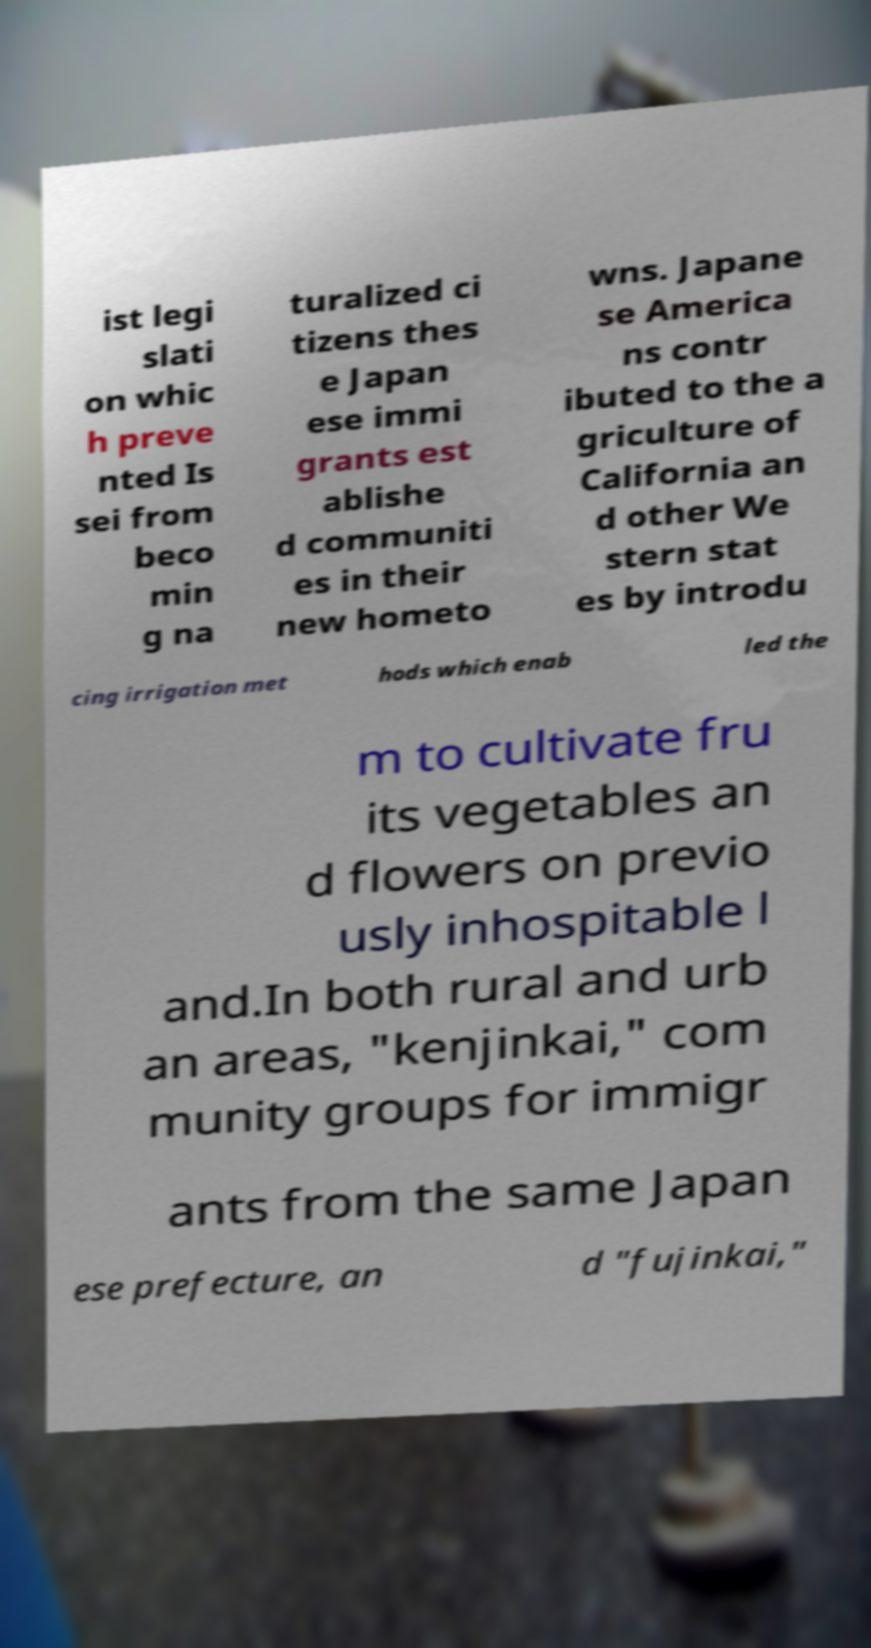Can you read and provide the text displayed in the image?This photo seems to have some interesting text. Can you extract and type it out for me? ist legi slati on whic h preve nted Is sei from beco min g na turalized ci tizens thes e Japan ese immi grants est ablishe d communiti es in their new hometo wns. Japane se America ns contr ibuted to the a griculture of California an d other We stern stat es by introdu cing irrigation met hods which enab led the m to cultivate fru its vegetables an d flowers on previo usly inhospitable l and.In both rural and urb an areas, "kenjinkai," com munity groups for immigr ants from the same Japan ese prefecture, an d "fujinkai," 